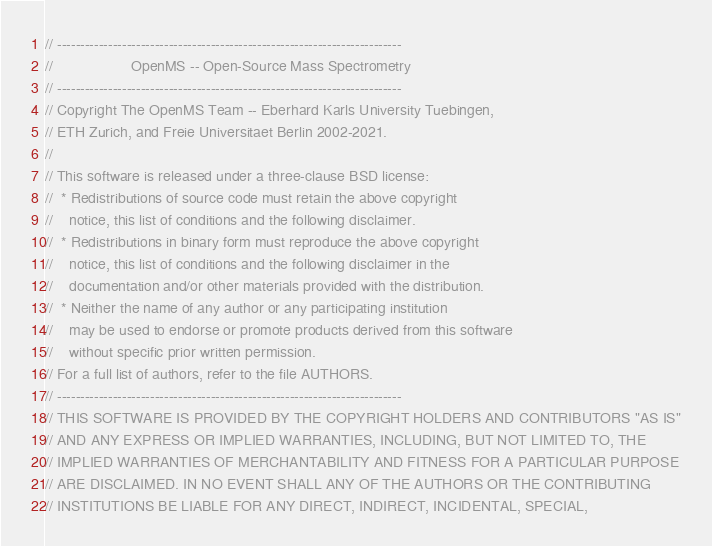Convert code to text. <code><loc_0><loc_0><loc_500><loc_500><_C++_>// --------------------------------------------------------------------------
//                   OpenMS -- Open-Source Mass Spectrometry
// --------------------------------------------------------------------------
// Copyright The OpenMS Team -- Eberhard Karls University Tuebingen,
// ETH Zurich, and Freie Universitaet Berlin 2002-2021.
//
// This software is released under a three-clause BSD license:
//  * Redistributions of source code must retain the above copyright
//    notice, this list of conditions and the following disclaimer.
//  * Redistributions in binary form must reproduce the above copyright
//    notice, this list of conditions and the following disclaimer in the
//    documentation and/or other materials provided with the distribution.
//  * Neither the name of any author or any participating institution
//    may be used to endorse or promote products derived from this software
//    without specific prior written permission.
// For a full list of authors, refer to the file AUTHORS.
// --------------------------------------------------------------------------
// THIS SOFTWARE IS PROVIDED BY THE COPYRIGHT HOLDERS AND CONTRIBUTORS "AS IS"
// AND ANY EXPRESS OR IMPLIED WARRANTIES, INCLUDING, BUT NOT LIMITED TO, THE
// IMPLIED WARRANTIES OF MERCHANTABILITY AND FITNESS FOR A PARTICULAR PURPOSE
// ARE DISCLAIMED. IN NO EVENT SHALL ANY OF THE AUTHORS OR THE CONTRIBUTING
// INSTITUTIONS BE LIABLE FOR ANY DIRECT, INDIRECT, INCIDENTAL, SPECIAL,</code> 